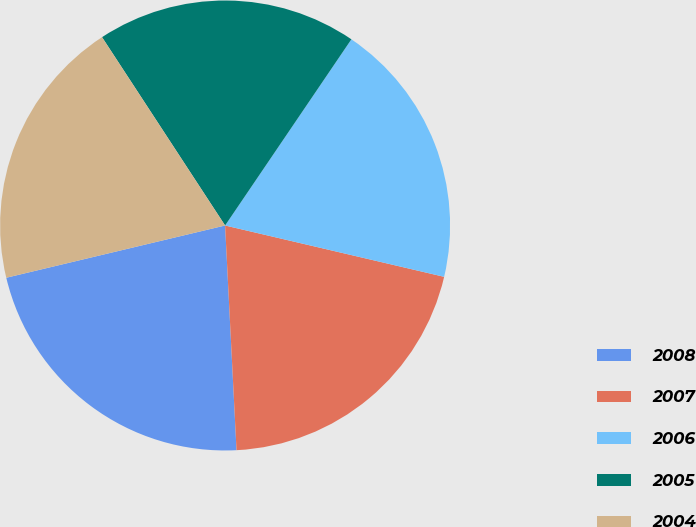Convert chart to OTSL. <chart><loc_0><loc_0><loc_500><loc_500><pie_chart><fcel>2008<fcel>2007<fcel>2006<fcel>2005<fcel>2004<nl><fcel>22.08%<fcel>20.53%<fcel>19.18%<fcel>18.7%<fcel>19.52%<nl></chart> 